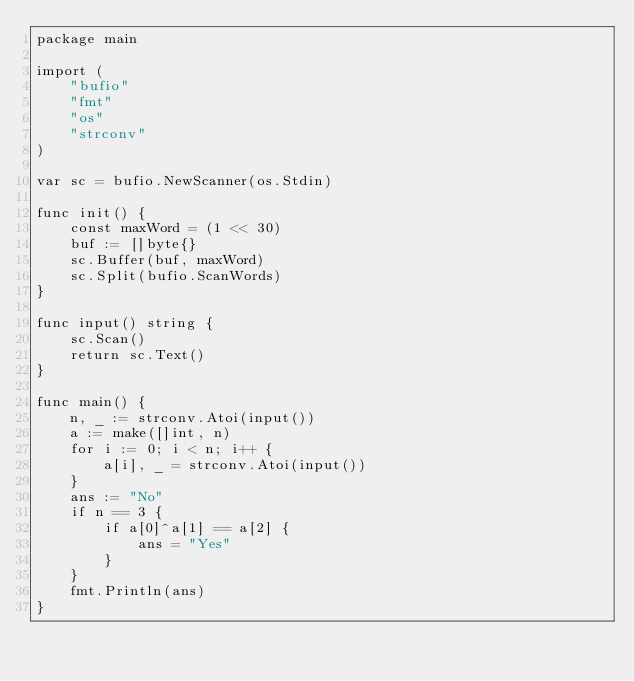Convert code to text. <code><loc_0><loc_0><loc_500><loc_500><_Go_>package main

import (
	"bufio"
	"fmt"
	"os"
	"strconv"
)

var sc = bufio.NewScanner(os.Stdin)

func init() {
	const maxWord = (1 << 30)
	buf := []byte{}
	sc.Buffer(buf, maxWord)
	sc.Split(bufio.ScanWords)
}

func input() string {
	sc.Scan()
	return sc.Text()
}

func main() {
	n, _ := strconv.Atoi(input())
	a := make([]int, n)
	for i := 0; i < n; i++ {
		a[i], _ = strconv.Atoi(input())
	}
	ans := "No"
	if n == 3 {
		if a[0]^a[1] == a[2] {
			ans = "Yes"
		}
	}
	fmt.Println(ans)
}
</code> 